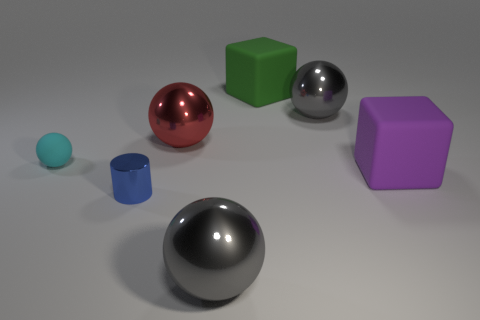Add 2 tiny blue metallic objects. How many objects exist? 9 Subtract all cylinders. How many objects are left? 6 Subtract 0 brown cylinders. How many objects are left? 7 Subtract all cyan rubber spheres. Subtract all cyan matte things. How many objects are left? 5 Add 1 small cylinders. How many small cylinders are left? 2 Add 1 blue things. How many blue things exist? 2 